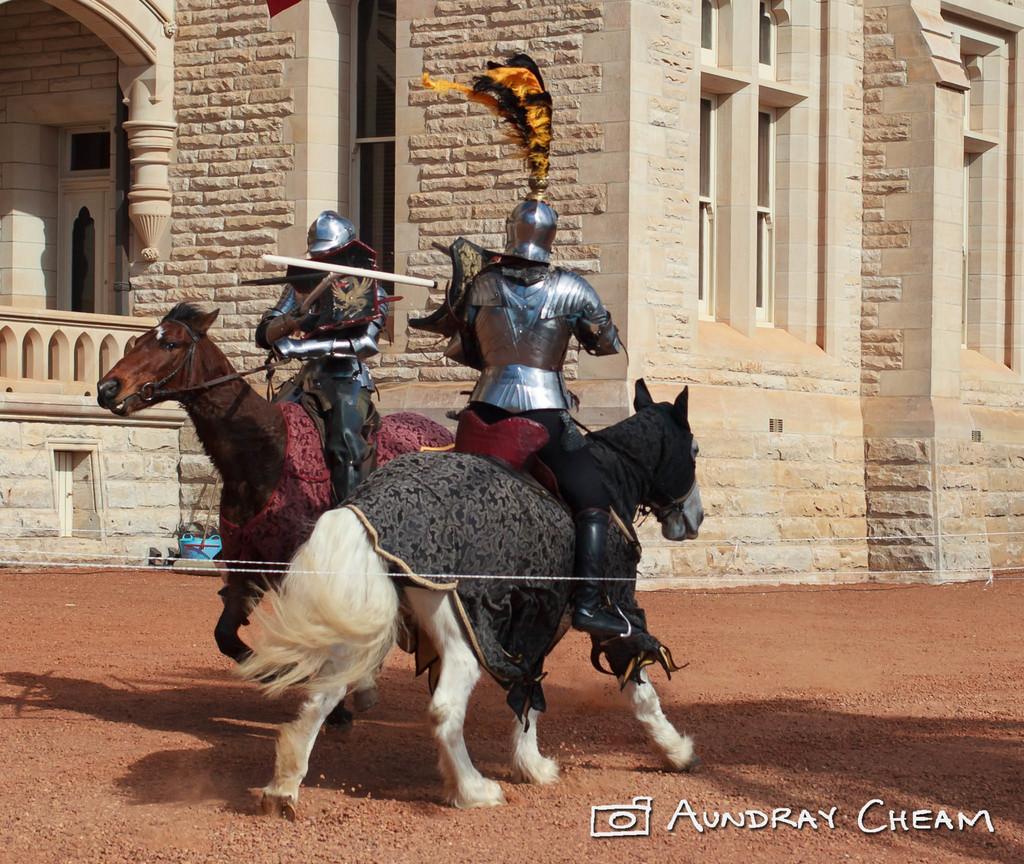Please provide a concise description of this image. In this image we can see there are people sitting on the horse and holding a stick. And at the back there is a building and a blue color object. 